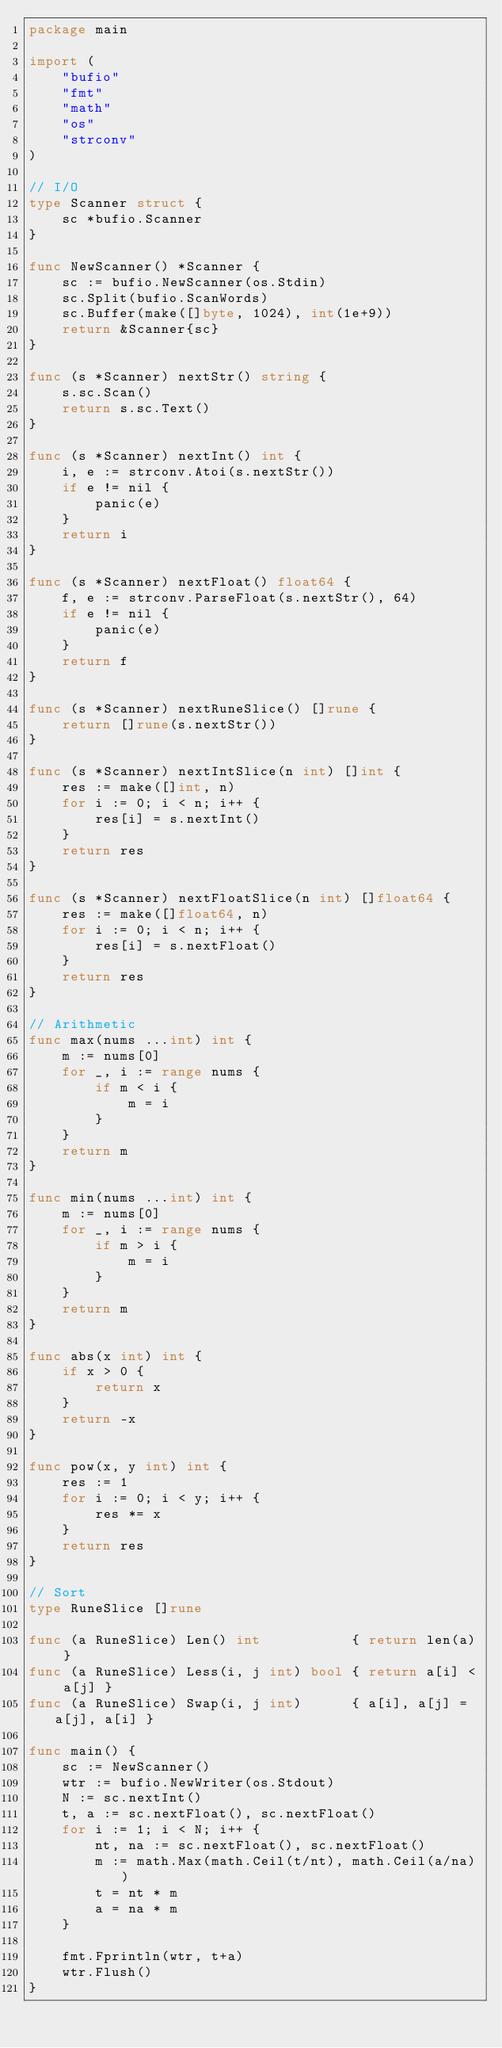Convert code to text. <code><loc_0><loc_0><loc_500><loc_500><_Go_>package main

import (
	"bufio"
	"fmt"
	"math"
	"os"
	"strconv"
)

// I/O
type Scanner struct {
	sc *bufio.Scanner
}

func NewScanner() *Scanner {
	sc := bufio.NewScanner(os.Stdin)
	sc.Split(bufio.ScanWords)
	sc.Buffer(make([]byte, 1024), int(1e+9))
	return &Scanner{sc}
}

func (s *Scanner) nextStr() string {
	s.sc.Scan()
	return s.sc.Text()
}

func (s *Scanner) nextInt() int {
	i, e := strconv.Atoi(s.nextStr())
	if e != nil {
		panic(e)
	}
	return i
}

func (s *Scanner) nextFloat() float64 {
	f, e := strconv.ParseFloat(s.nextStr(), 64)
	if e != nil {
		panic(e)
	}
	return f
}

func (s *Scanner) nextRuneSlice() []rune {
	return []rune(s.nextStr())
}

func (s *Scanner) nextIntSlice(n int) []int {
	res := make([]int, n)
	for i := 0; i < n; i++ {
		res[i] = s.nextInt()
	}
	return res
}

func (s *Scanner) nextFloatSlice(n int) []float64 {
	res := make([]float64, n)
	for i := 0; i < n; i++ {
		res[i] = s.nextFloat()
	}
	return res
}

// Arithmetic
func max(nums ...int) int {
	m := nums[0]
	for _, i := range nums {
		if m < i {
			m = i
		}
	}
	return m
}

func min(nums ...int) int {
	m := nums[0]
	for _, i := range nums {
		if m > i {
			m = i
		}
	}
	return m
}

func abs(x int) int {
	if x > 0 {
		return x
	}
	return -x
}

func pow(x, y int) int {
	res := 1
	for i := 0; i < y; i++ {
		res *= x
	}
	return res
}

// Sort
type RuneSlice []rune

func (a RuneSlice) Len() int           { return len(a) }
func (a RuneSlice) Less(i, j int) bool { return a[i] < a[j] }
func (a RuneSlice) Swap(i, j int)      { a[i], a[j] = a[j], a[i] }

func main() {
	sc := NewScanner()
	wtr := bufio.NewWriter(os.Stdout)
	N := sc.nextInt()
	t, a := sc.nextFloat(), sc.nextFloat()
	for i := 1; i < N; i++ {
		nt, na := sc.nextFloat(), sc.nextFloat()
		m := math.Max(math.Ceil(t/nt), math.Ceil(a/na))
		t = nt * m
		a = na * m
	}

	fmt.Fprintln(wtr, t+a)
	wtr.Flush()
}
</code> 